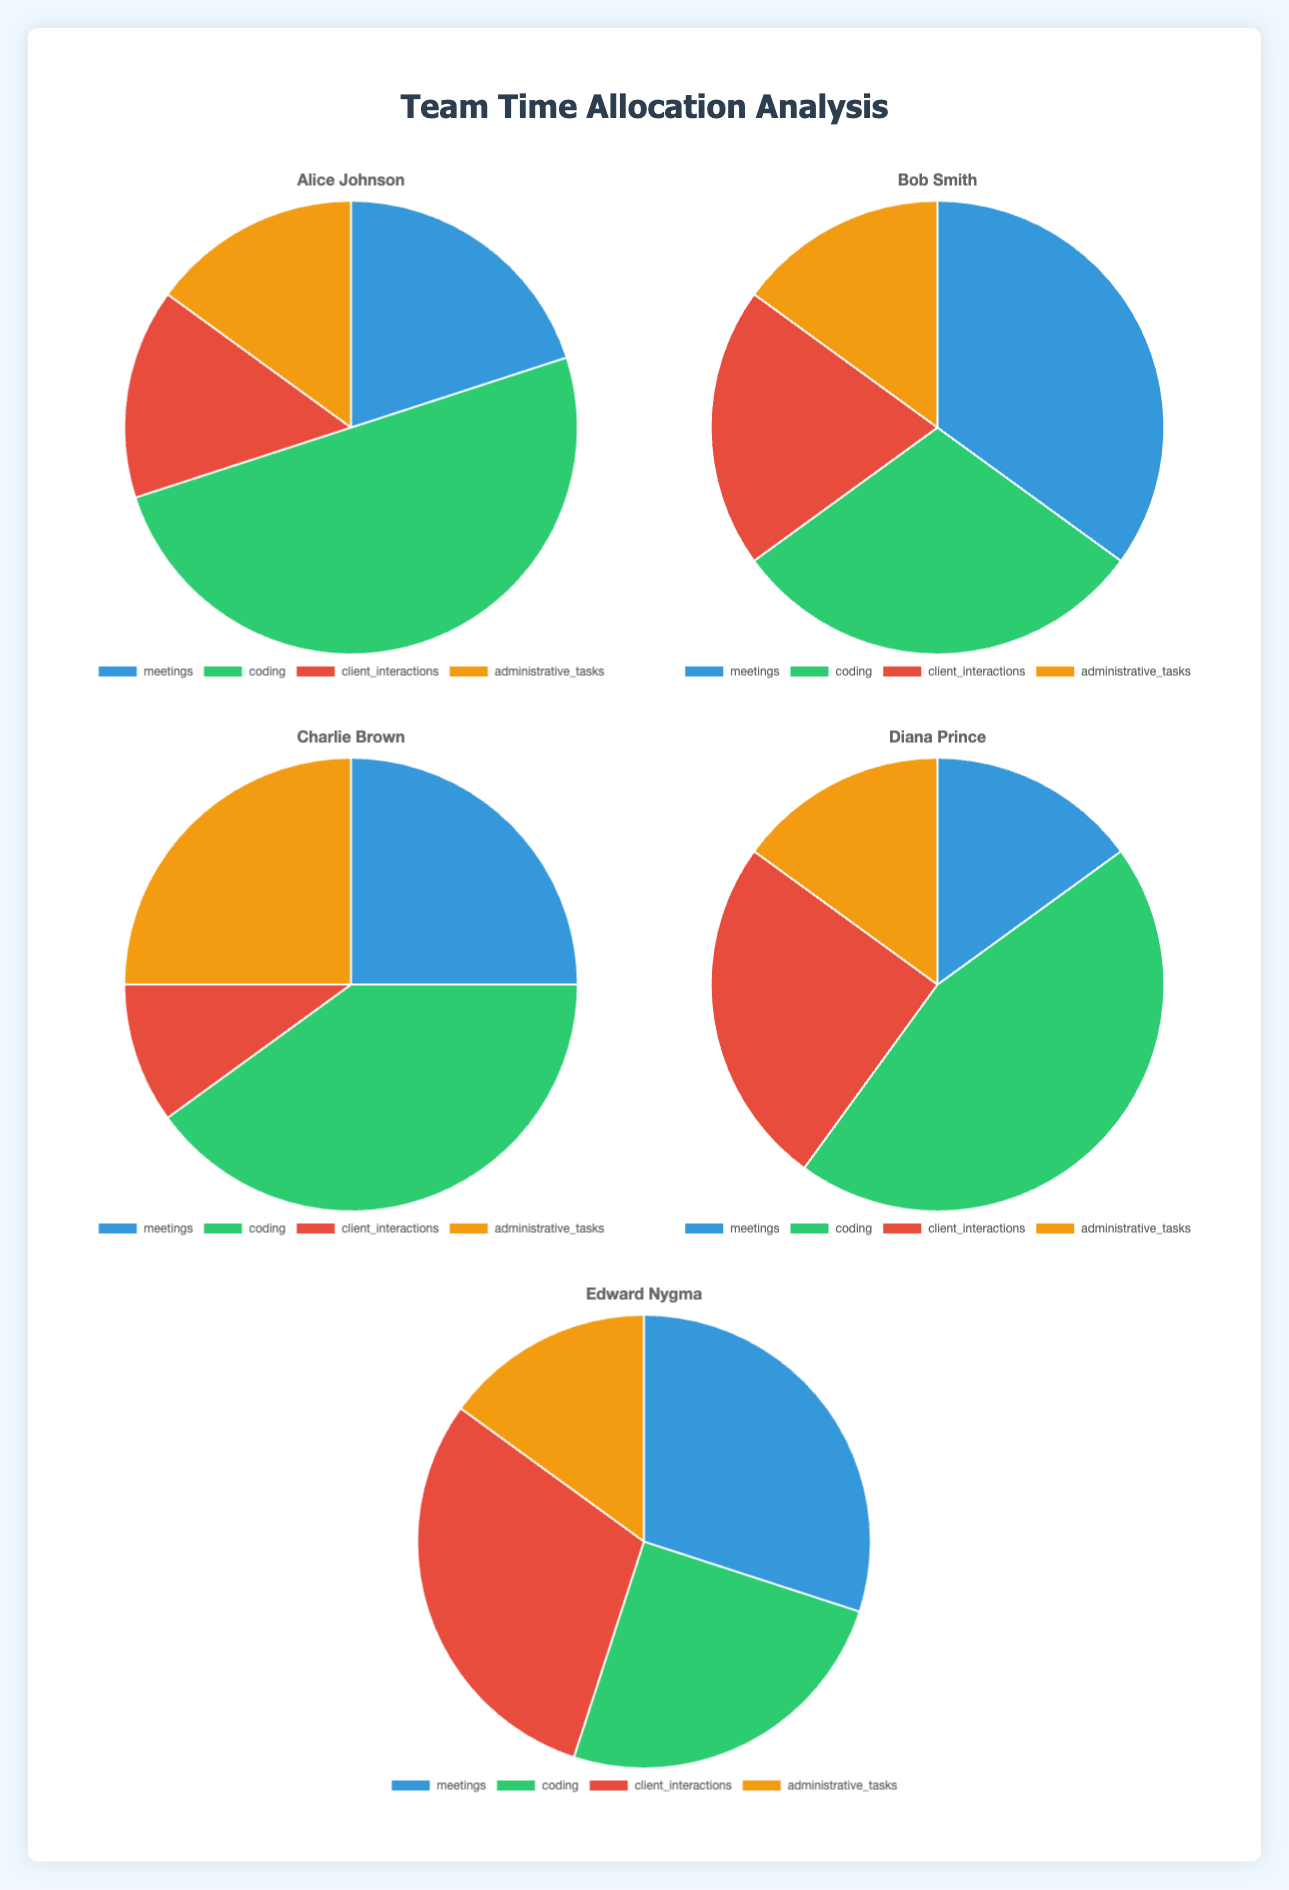What percentage of time does Alice Johnson spend on coding and administrative tasks combined? Alice Johnson spends 50% of her time on coding and 15% on administrative tasks. Summing these two percentages gives us 50% + 15% = 65%.
Answer: 65% Who spends a greater proportion of time on meetings, Bob Smith or Edward Nygma? Bob Smith spends 35% of his time on meetings, while Edward Nygma spends 30%. 35% is greater than 30%.
Answer: Bob Smith What activity does Charlie Brown spend the least amount of time on? By looking at Charlie Brown's pie chart, we see he spends 10% on client interactions, which is the smallest percentage among his activities.
Answer: Client interactions How much more time does Diana Prince spend on client interactions compared to Bob Smith? Diana spends 25% of her time on client interactions, whereas Bob spends 20%. The difference is 25% - 20% = 5%.
Answer: 5% Compare the proportion of time spent on coding by Alice Johnson and Diana Prince. Who spends more, and by how much? Alice spends 50% on coding, while Diana spends 45%. The difference is 50% - 45% = 5%. So, Alice spends 5% more time coding compared to Diana.
Answer: Alice by 5% Which team member has the most balanced allocation of time across all activities? Charlie Brown’s chart shows 25% meetings, 40% coding, 10% client interactions, and 25% administrative tasks, giving a relatively balanced allocation.
Answer: Charlie Brown If we consider workload balance important, who should reduce their administrative tasks? Both Alice Johnson and Diana Prince spend 15% of their time on administrative tasks, which is the lowest among all members. So, they might need to further reduce or balance other tasks.
Answer: Alice Johnson or Diana Prince What is the difference between the highest and lowest proportion of time spent on any single activity by Edward Nygma? Edward spends 30% each on meetings and client interactions, which are the highest, and 15% on administrative tasks, which is the lowest. The difference is 30% - 15% = 15%.
Answer: 15% 